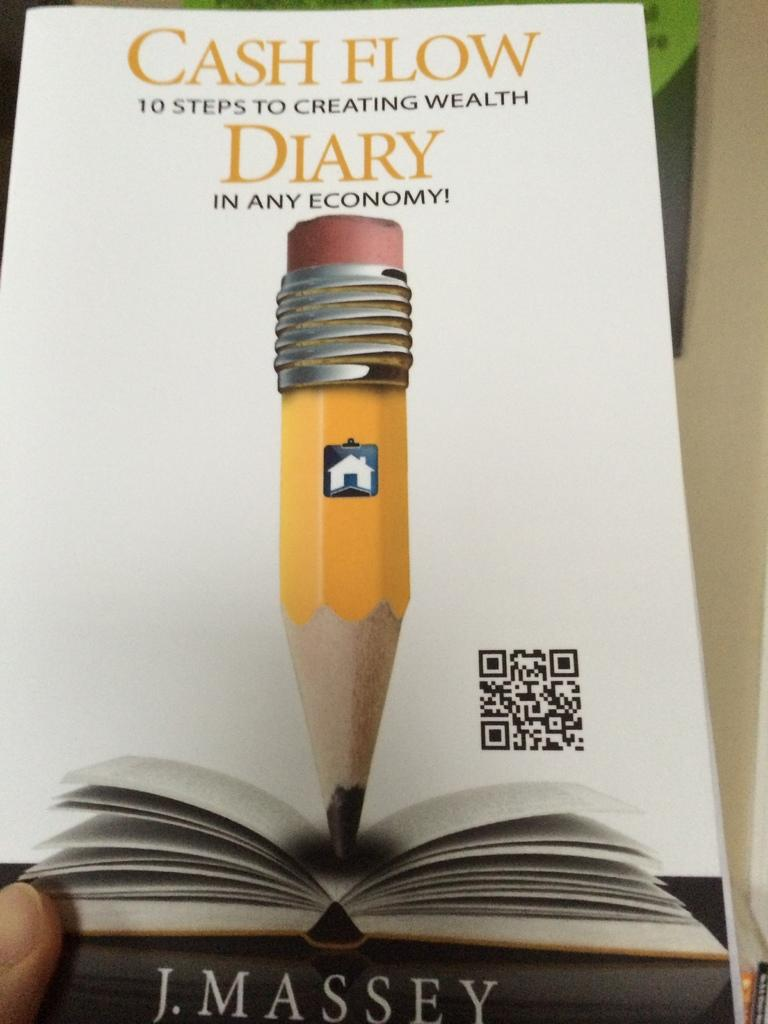<image>
Write a terse but informative summary of the picture. A book by J. Massey on Cash Flow. 